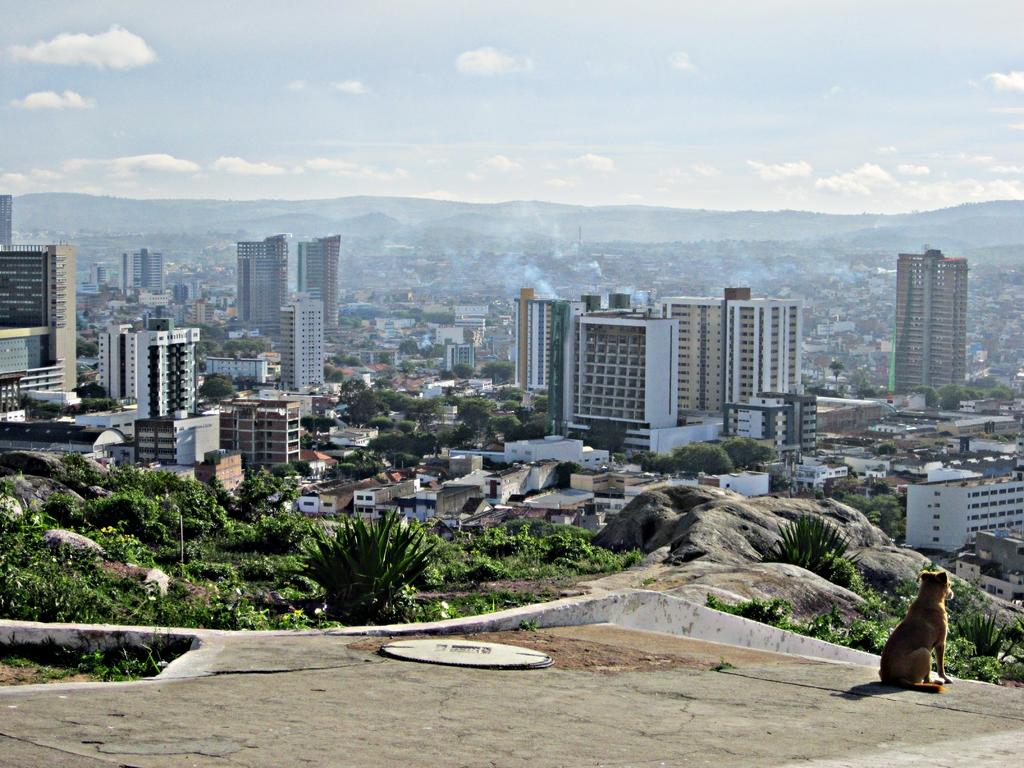What type of animal can be seen on the right side of the image? There is a dog on the right side of the image. What is the color of the dog? The dog is brown in color. What can be seen in the background of the image? In the background of the image, there are clouds, buildings, towers, smoke, trees, plants, and grass. Can you describe the color of the sky in the image? The sky is not mentioned in the provided facts, so we cannot determine its color from the information given. What type of pet is the zinc in the image? There is no mention of zinc or a pet in the image, so we cannot answer that question. How many dogs are present in the image? The image only features one dog, as mentioned in the provided facts. 